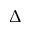<formula> <loc_0><loc_0><loc_500><loc_500>\Delta</formula> 